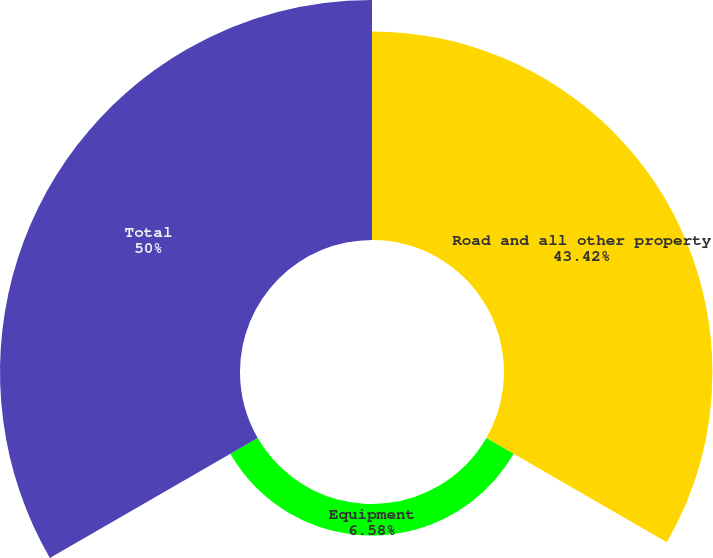Convert chart. <chart><loc_0><loc_0><loc_500><loc_500><pie_chart><fcel>Road and all other property<fcel>Equipment<fcel>Total<nl><fcel>43.42%<fcel>6.58%<fcel>50.0%<nl></chart> 